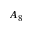Convert formula to latex. <formula><loc_0><loc_0><loc_500><loc_500>A _ { 8 }</formula> 